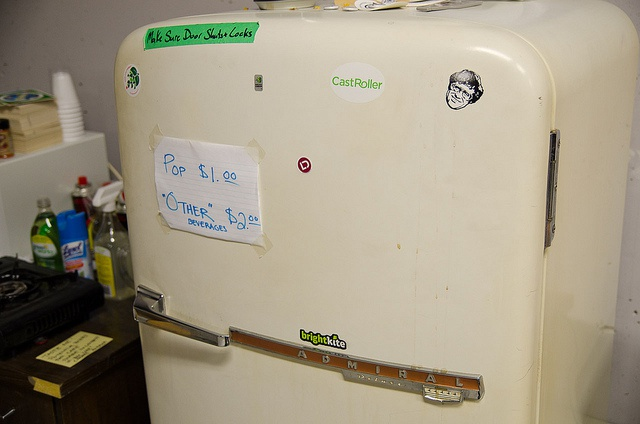Describe the objects in this image and their specific colors. I can see refrigerator in black and tan tones, bottle in black, olive, and gray tones, bottle in black, gray, olive, and darkgreen tones, cup in black, darkgray, and gray tones, and book in black and olive tones in this image. 